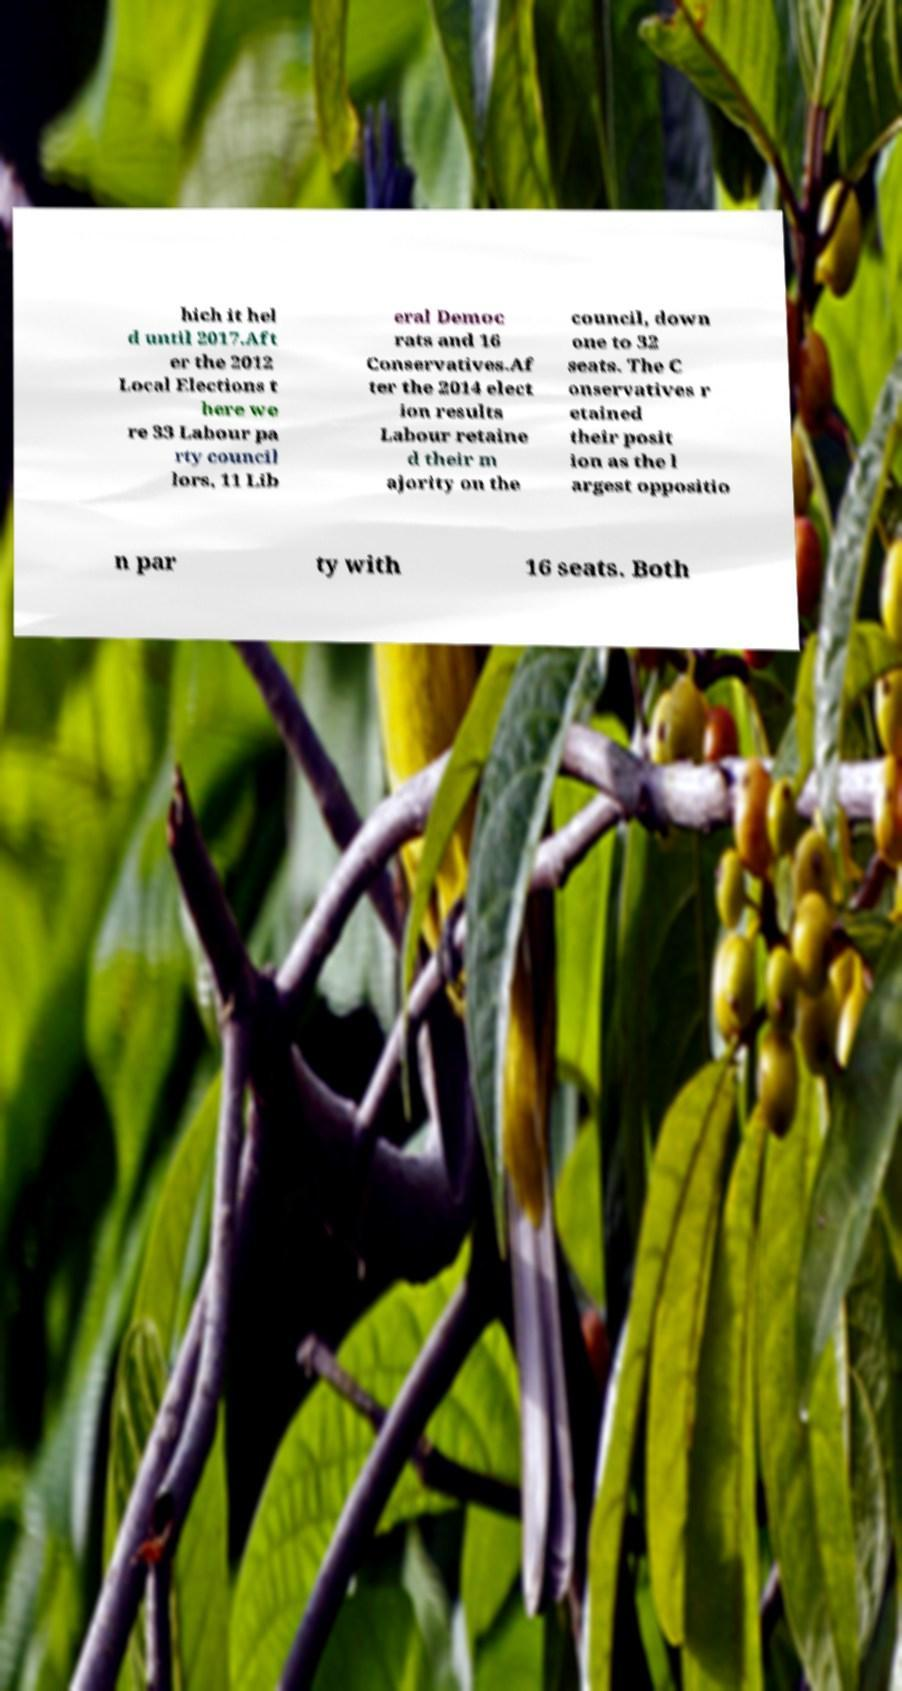For documentation purposes, I need the text within this image transcribed. Could you provide that? hich it hel d until 2017.Aft er the 2012 Local Elections t here we re 33 Labour pa rty council lors, 11 Lib eral Democ rats and 16 Conservatives.Af ter the 2014 elect ion results Labour retaine d their m ajority on the council, down one to 32 seats. The C onservatives r etained their posit ion as the l argest oppositio n par ty with 16 seats. Both 